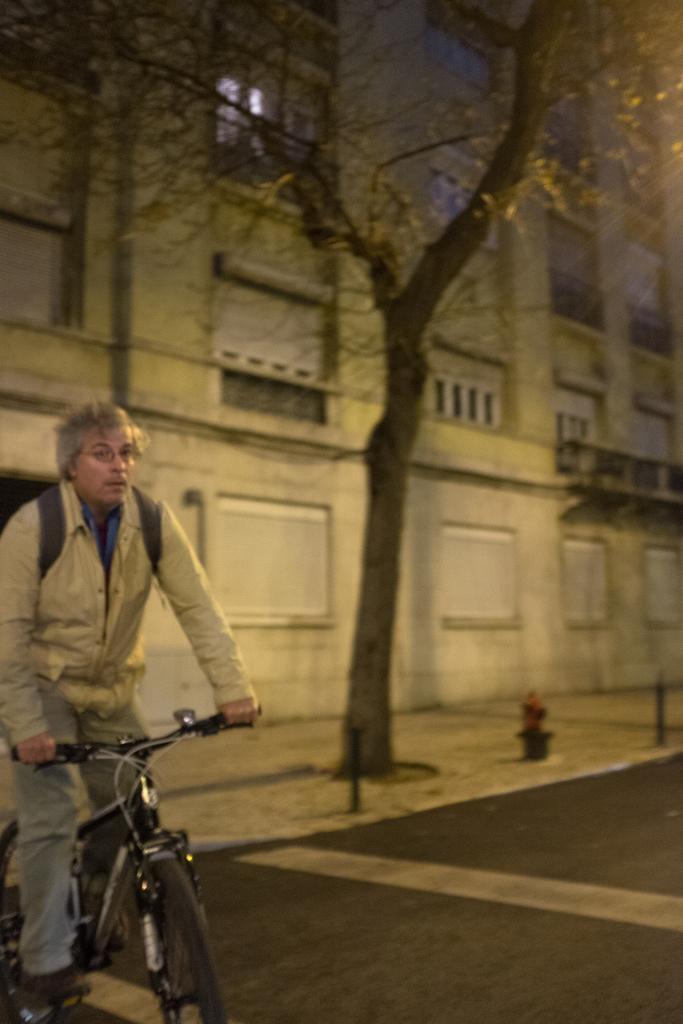Describe this image in one or two sentences. In the left bottom, a person is riding a bicycle. In the background a building is visible of white in color. In the middle a tree is visible. This image is taken during night time on the road. 